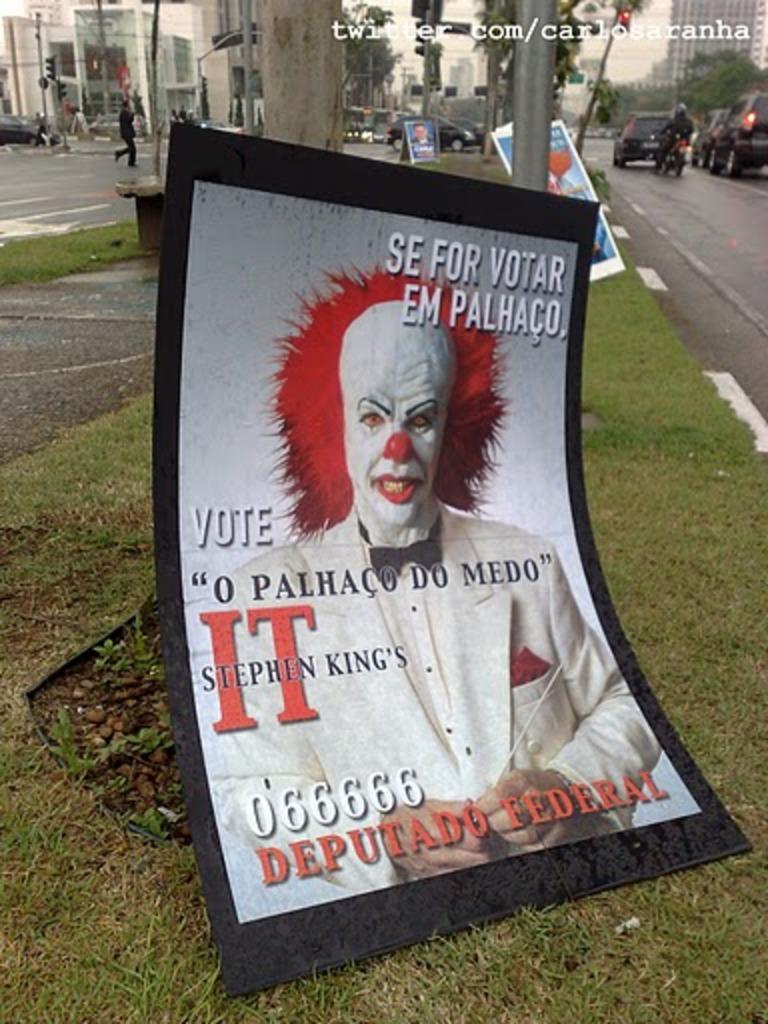What is the website on the top right?
Keep it short and to the point. Twitter.com/carlosaranha. 